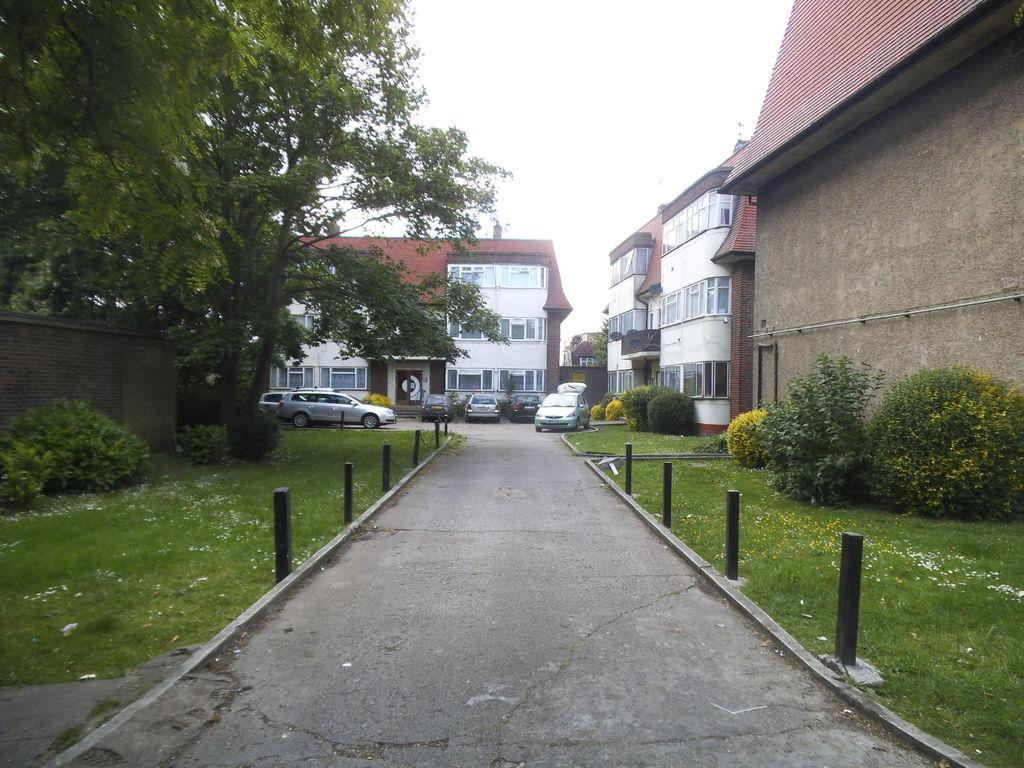What type of landscape is depicted in the image? There is glass land in the image. Where are plants located in the image? Plants can be seen on both the right and left sides of the image. What structures are present in the center of the image? There are houses and trees in the center of the image. How many yaks can be seen grazing in the glass land? There are no yaks present in the image; it features glass land, plants, houses, and trees. What type of bottle is visible on the left side of the image? There is no bottle present on the left side of the image. 